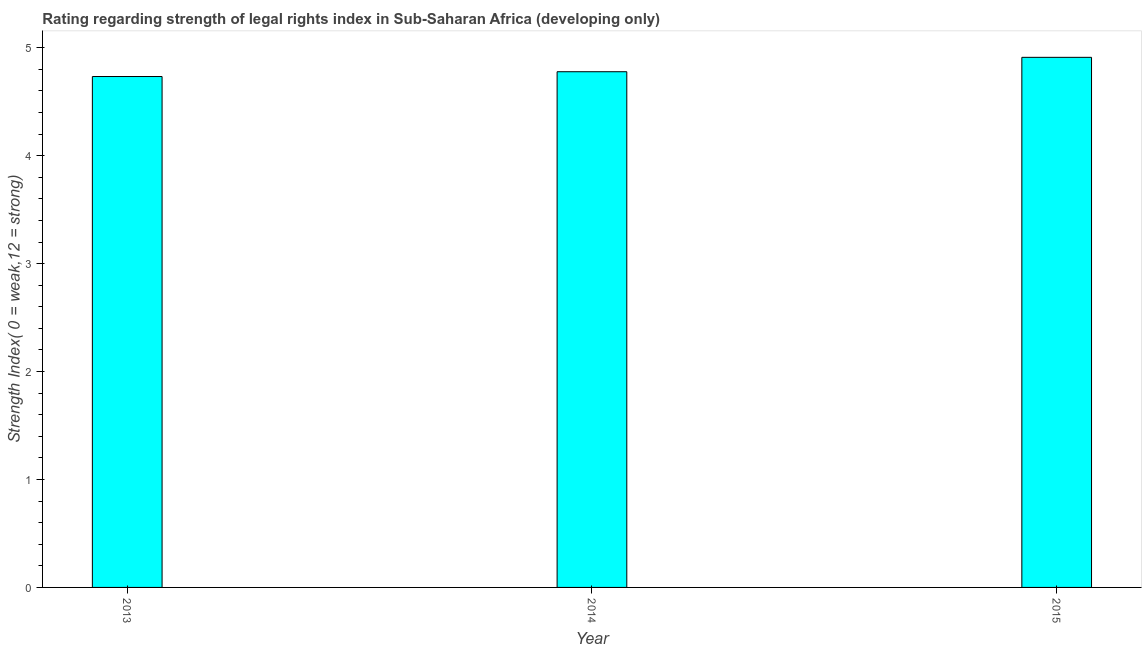What is the title of the graph?
Provide a succinct answer. Rating regarding strength of legal rights index in Sub-Saharan Africa (developing only). What is the label or title of the Y-axis?
Your answer should be very brief. Strength Index( 0 = weak,12 = strong). What is the strength of legal rights index in 2015?
Offer a very short reply. 4.91. Across all years, what is the maximum strength of legal rights index?
Provide a succinct answer. 4.91. Across all years, what is the minimum strength of legal rights index?
Ensure brevity in your answer.  4.73. In which year was the strength of legal rights index maximum?
Offer a very short reply. 2015. In which year was the strength of legal rights index minimum?
Provide a succinct answer. 2013. What is the sum of the strength of legal rights index?
Ensure brevity in your answer.  14.42. What is the difference between the strength of legal rights index in 2013 and 2015?
Keep it short and to the point. -0.18. What is the average strength of legal rights index per year?
Give a very brief answer. 4.81. What is the median strength of legal rights index?
Offer a terse response. 4.78. In how many years, is the strength of legal rights index greater than 3.8 ?
Ensure brevity in your answer.  3. Do a majority of the years between 2015 and 2013 (inclusive) have strength of legal rights index greater than 3 ?
Offer a very short reply. Yes. What is the ratio of the strength of legal rights index in 2013 to that in 2015?
Offer a very short reply. 0.96. Is the strength of legal rights index in 2013 less than that in 2014?
Offer a terse response. Yes. Is the difference between the strength of legal rights index in 2013 and 2015 greater than the difference between any two years?
Your answer should be very brief. Yes. What is the difference between the highest and the second highest strength of legal rights index?
Offer a terse response. 0.13. Is the sum of the strength of legal rights index in 2013 and 2014 greater than the maximum strength of legal rights index across all years?
Offer a very short reply. Yes. What is the difference between the highest and the lowest strength of legal rights index?
Your response must be concise. 0.18. In how many years, is the strength of legal rights index greater than the average strength of legal rights index taken over all years?
Keep it short and to the point. 1. What is the difference between two consecutive major ticks on the Y-axis?
Ensure brevity in your answer.  1. What is the Strength Index( 0 = weak,12 = strong) of 2013?
Provide a short and direct response. 4.73. What is the Strength Index( 0 = weak,12 = strong) in 2014?
Keep it short and to the point. 4.78. What is the Strength Index( 0 = weak,12 = strong) in 2015?
Keep it short and to the point. 4.91. What is the difference between the Strength Index( 0 = weak,12 = strong) in 2013 and 2014?
Keep it short and to the point. -0.04. What is the difference between the Strength Index( 0 = weak,12 = strong) in 2013 and 2015?
Your answer should be compact. -0.18. What is the difference between the Strength Index( 0 = weak,12 = strong) in 2014 and 2015?
Ensure brevity in your answer.  -0.13. What is the ratio of the Strength Index( 0 = weak,12 = strong) in 2014 to that in 2015?
Ensure brevity in your answer.  0.97. 